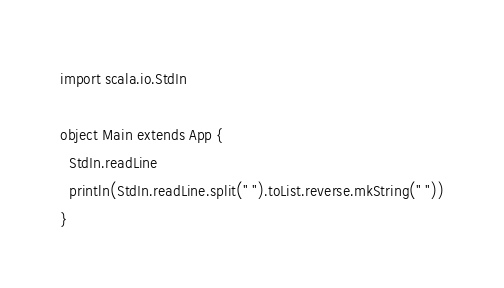Convert code to text. <code><loc_0><loc_0><loc_500><loc_500><_Scala_>import scala.io.StdIn

object Main extends App {
  StdIn.readLine
  println(StdIn.readLine.split(" ").toList.reverse.mkString(" "))
}</code> 